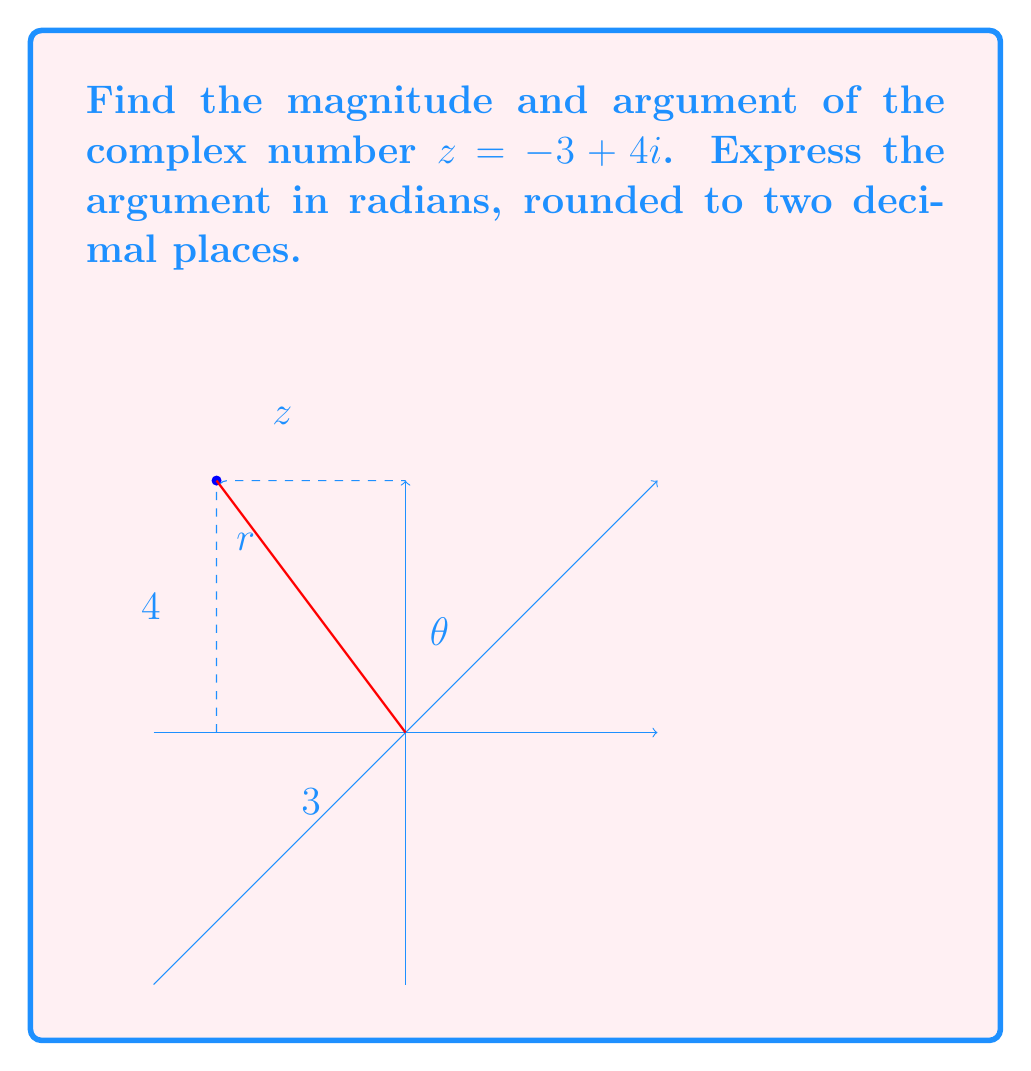Help me with this question. To find the magnitude and argument of a complex number $z = a + bi$, we use the following formulas:

1. Magnitude: $r = |z| = \sqrt{a^2 + b^2}$
2. Argument: $\theta = \arg(z) = \tan^{-1}(\frac{b}{a})$

For $z = -3 + 4i$:

1. Magnitude:
   $$r = |z| = \sqrt{(-3)^2 + 4^2} = \sqrt{9 + 16} = \sqrt{25} = 5$$

2. Argument:
   We can't directly use the arctangent formula because $a$ is negative. We need to adjust our calculation:
   
   $$\theta = \tan^{-1}(\frac{4}{-3}) + \pi = \tan^{-1}(-\frac{4}{3}) + \pi$$
   
   Using a calculator:
   $$\theta \approx -0.9273 + \pi \approx 2.2143$$

   Rounded to two decimal places: $\theta \approx 2.21$ radians

Note: We add $\pi$ because the complex number is in the second quadrant (negative real part, positive imaginary part).
Answer: Magnitude: 5, Argument: 2.21 radians 